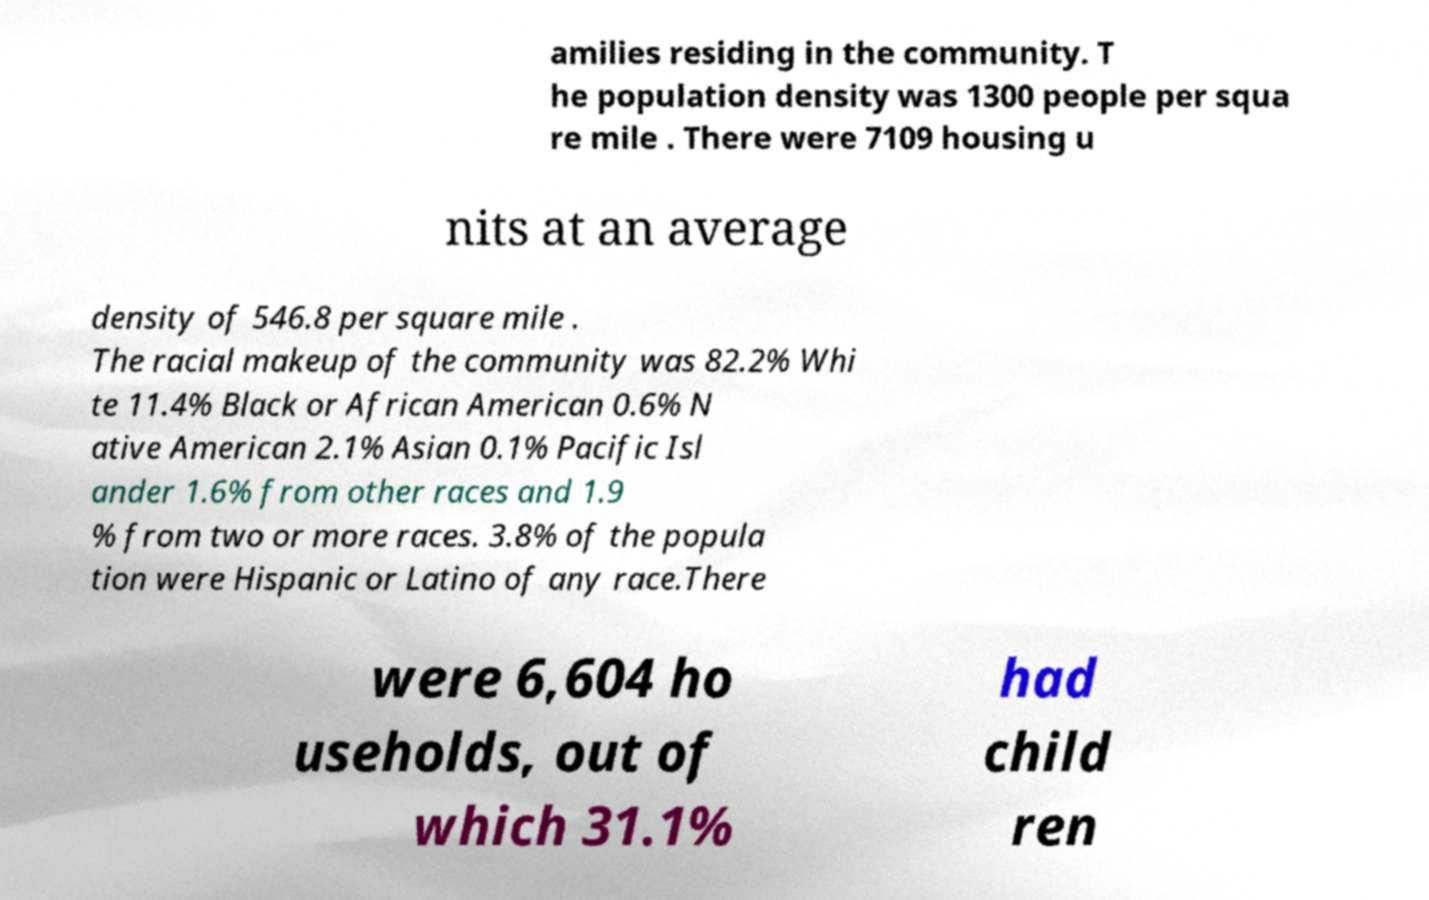Could you assist in decoding the text presented in this image and type it out clearly? amilies residing in the community. T he population density was 1300 people per squa re mile . There were 7109 housing u nits at an average density of 546.8 per square mile . The racial makeup of the community was 82.2% Whi te 11.4% Black or African American 0.6% N ative American 2.1% Asian 0.1% Pacific Isl ander 1.6% from other races and 1.9 % from two or more races. 3.8% of the popula tion were Hispanic or Latino of any race.There were 6,604 ho useholds, out of which 31.1% had child ren 